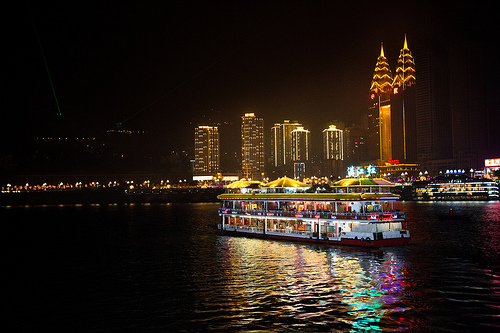Imagine the boat in the image is transporting a treasure. What could it be? Provide a backstory. The boat, seemingly an ordinary passenger vessel, is covertly transporting an ancient, mystical artifact known as the 'Heart of Lumina.' This artifact was unearthed by archaeologists in a forgotten temple deep within the city. Legend has it that the Heart of Lumina has the power to control the city's lights and energy, a gift from a benevolent deity meant to protect and sustain the city's prosperity. The boat is on a secret mission to relocate the artifact to a secure, undisclosed location to keep it safe from a shadowy organization that seeks to harness its power for nefarious purposes. Along its journey, unsuspecting passengers enjoy their evening, unaware of the precious cargo hidden in a heavily guarded compartment below deck, adding an air of mystery and adventure to an otherwise beautiful night on the water. 